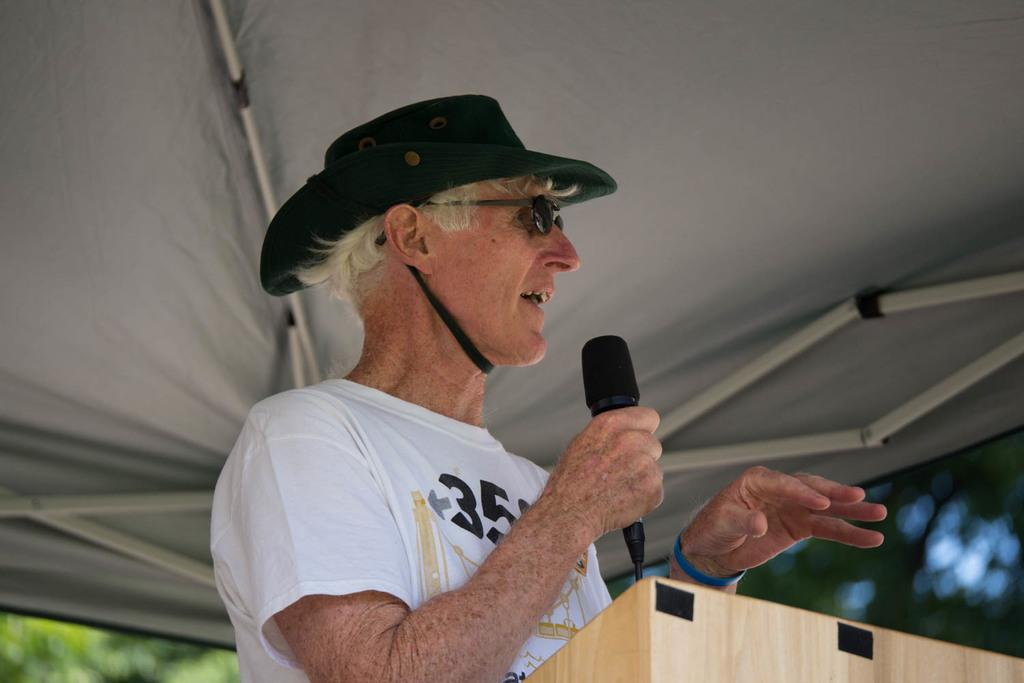What is the main subject of the image? There is a person in the image. What is the person wearing? The person is wearing a hat. What object is the person holding? The person is holding a microphone. What type of shelter is visible in the image? The person is under a tent. What type of bait is the person using to catch fish in the image? There is no indication of fishing or bait in the image; the person is holding a microphone and is under a tent. 